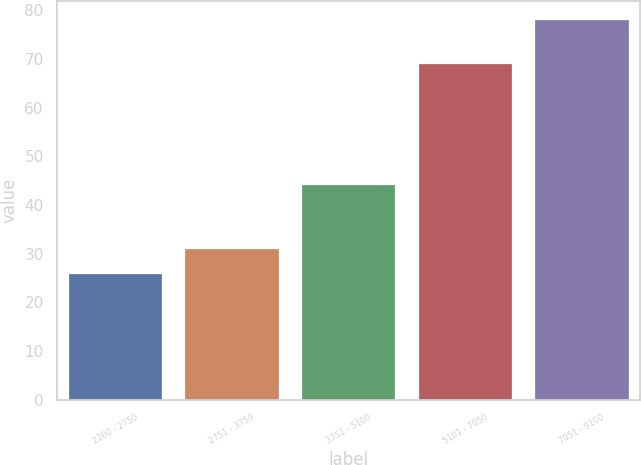Convert chart. <chart><loc_0><loc_0><loc_500><loc_500><bar_chart><fcel>2200 - 2750<fcel>2751 - 3750<fcel>3751 - 5100<fcel>5101 - 7050<fcel>7051 - 9100<nl><fcel>25.73<fcel>30.95<fcel>44.01<fcel>68.97<fcel>77.95<nl></chart> 